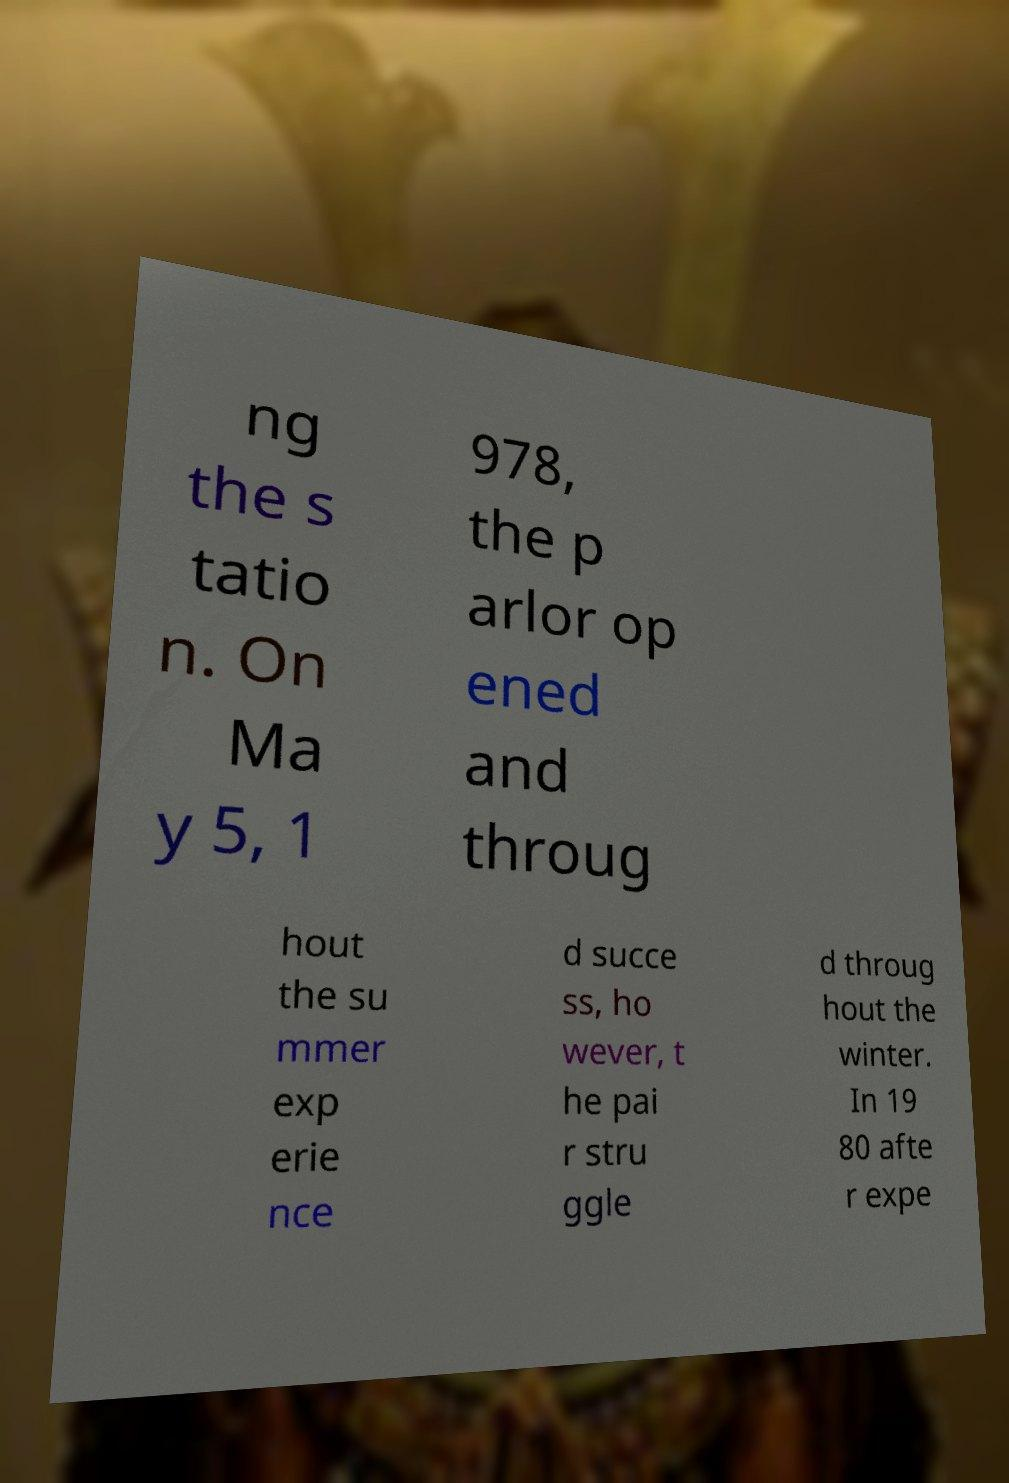There's text embedded in this image that I need extracted. Can you transcribe it verbatim? ng the s tatio n. On Ma y 5, 1 978, the p arlor op ened and throug hout the su mmer exp erie nce d succe ss, ho wever, t he pai r stru ggle d throug hout the winter. In 19 80 afte r expe 